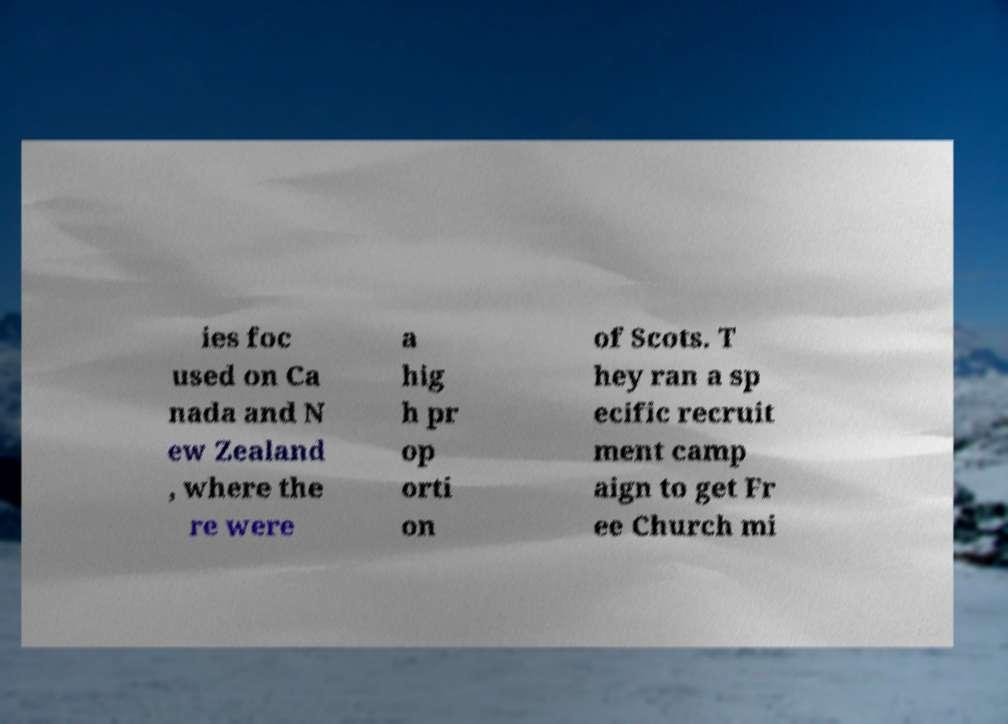Could you extract and type out the text from this image? ies foc used on Ca nada and N ew Zealand , where the re were a hig h pr op orti on of Scots. T hey ran a sp ecific recruit ment camp aign to get Fr ee Church mi 